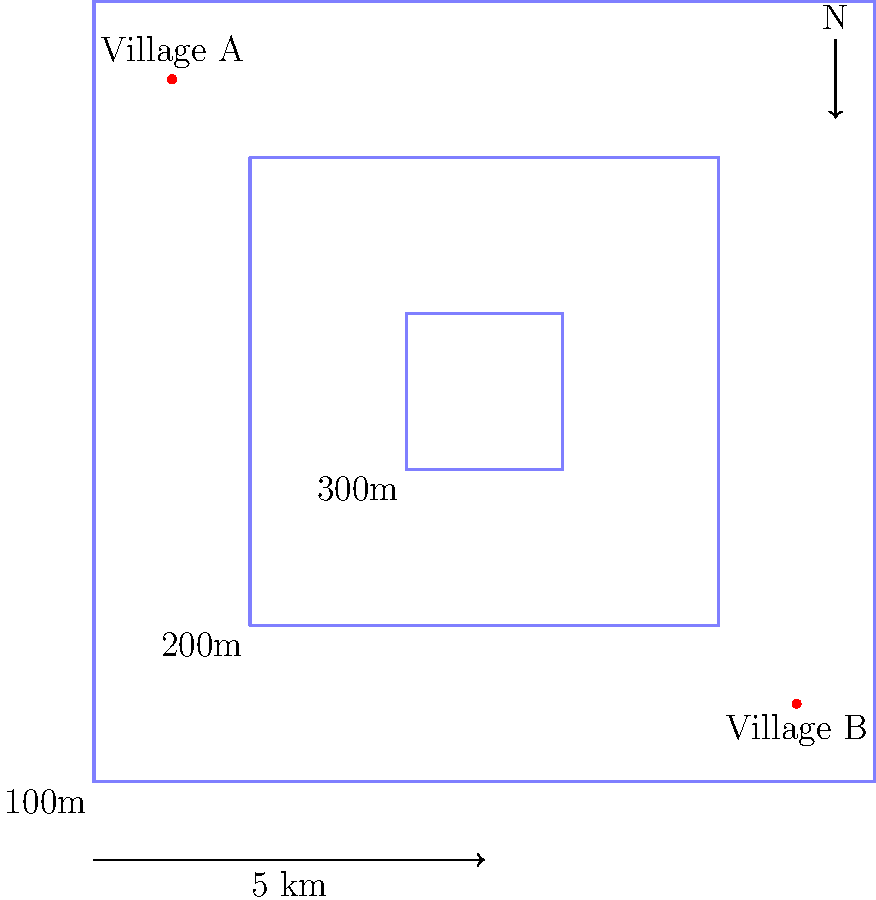Based on the topographical map provided, which route would be most suitable for constructing a road between Village A and Village B, considering both distance and elevation changes?

a) A direct straight line between the villages
b) Following the outermost contour line
c) A route that follows the middle contour line as much as possible
d) A zigzag pattern crossing all contour lines perpendicularly To determine the most suitable route for constructing a road between Village A and Village B, we need to consider both distance and elevation changes. Let's analyze each option:

1. A direct straight line between the villages:
   - This would be the shortest distance but would involve crossing all contour lines directly, resulting in steep elevation changes.

2. Following the outermost contour line:
   - This route would have minimal elevation changes but would be significantly longer than necessary.

3. A route that follows the middle contour line as much as possible:
   - This option provides a balance between distance and elevation changes.
   - It would involve a gradual ascent from Village A to the 200m contour line, then following it around to approach Village B, and finally a gradual descent to Village B.

4. A zigzag pattern crossing all contour lines perpendicularly:
   - While this would create a more gradual elevation change, it would significantly increase the total distance and require many sharp turns.

The most suitable route would be option c, following the middle contour line as much as possible. This approach:
- Minimizes steep elevation changes, making construction and maintenance easier.
- Provides a reasonable balance between distance and elevation change.
- Allows for a more gradual ascent and descent, improving safety and reducing erosion risks.
- Is likely to be more cost-effective in terms of construction and long-term maintenance.
Answer: c) A route that follows the middle contour line as much as possible 